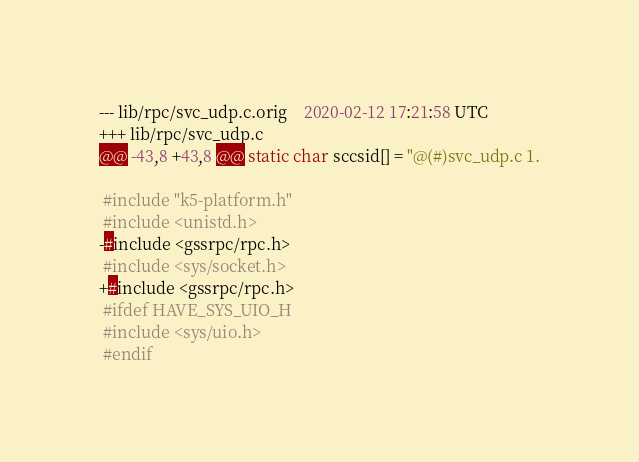<code> <loc_0><loc_0><loc_500><loc_500><_C_>--- lib/rpc/svc_udp.c.orig	2020-02-12 17:21:58 UTC
+++ lib/rpc/svc_udp.c
@@ -43,8 +43,8 @@ static char sccsid[] = "@(#)svc_udp.c 1.
 
 #include "k5-platform.h"
 #include <unistd.h>
-#include <gssrpc/rpc.h>
 #include <sys/socket.h>
+#include <gssrpc/rpc.h>
 #ifdef HAVE_SYS_UIO_H
 #include <sys/uio.h>
 #endif
</code> 